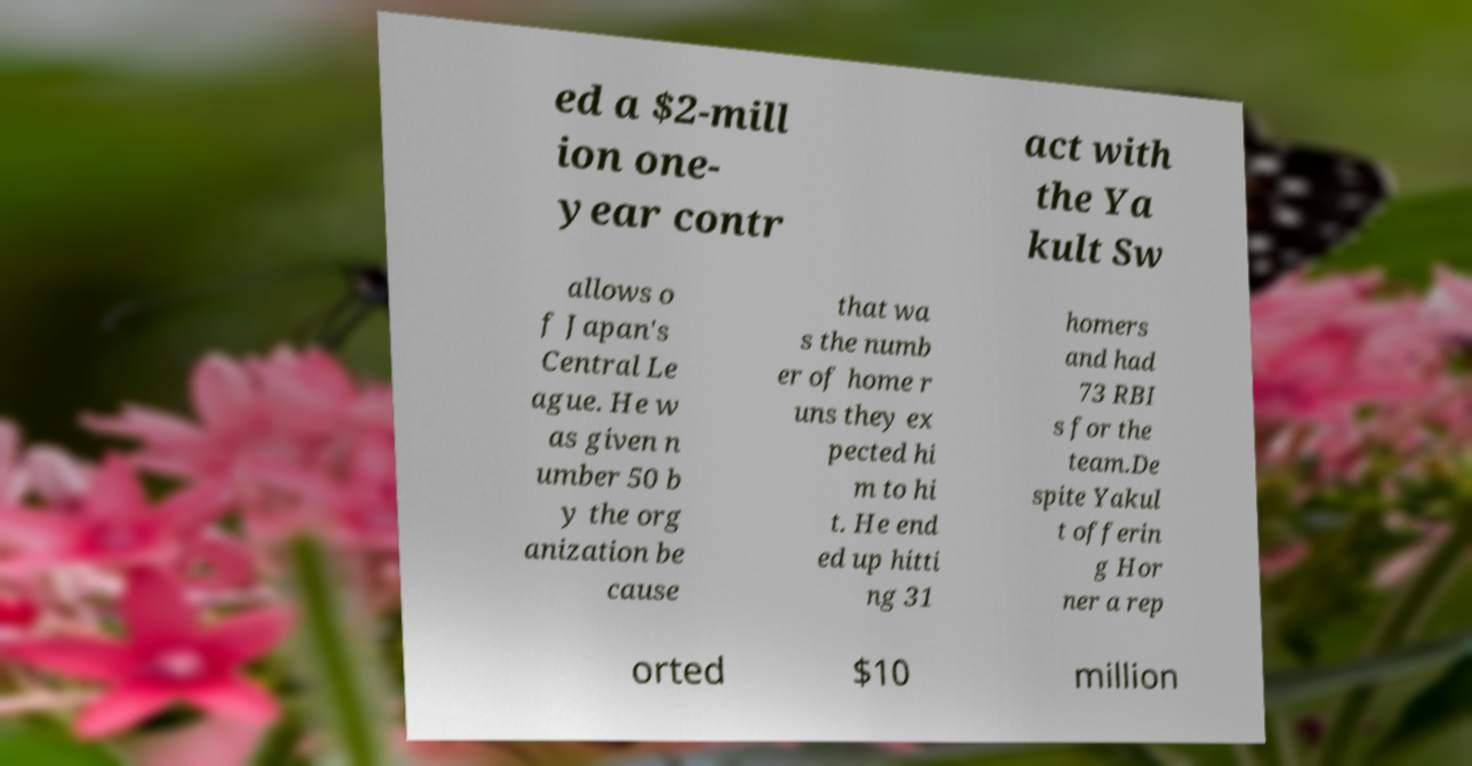Please identify and transcribe the text found in this image. ed a $2-mill ion one- year contr act with the Ya kult Sw allows o f Japan's Central Le ague. He w as given n umber 50 b y the org anization be cause that wa s the numb er of home r uns they ex pected hi m to hi t. He end ed up hitti ng 31 homers and had 73 RBI s for the team.De spite Yakul t offerin g Hor ner a rep orted $10 million 